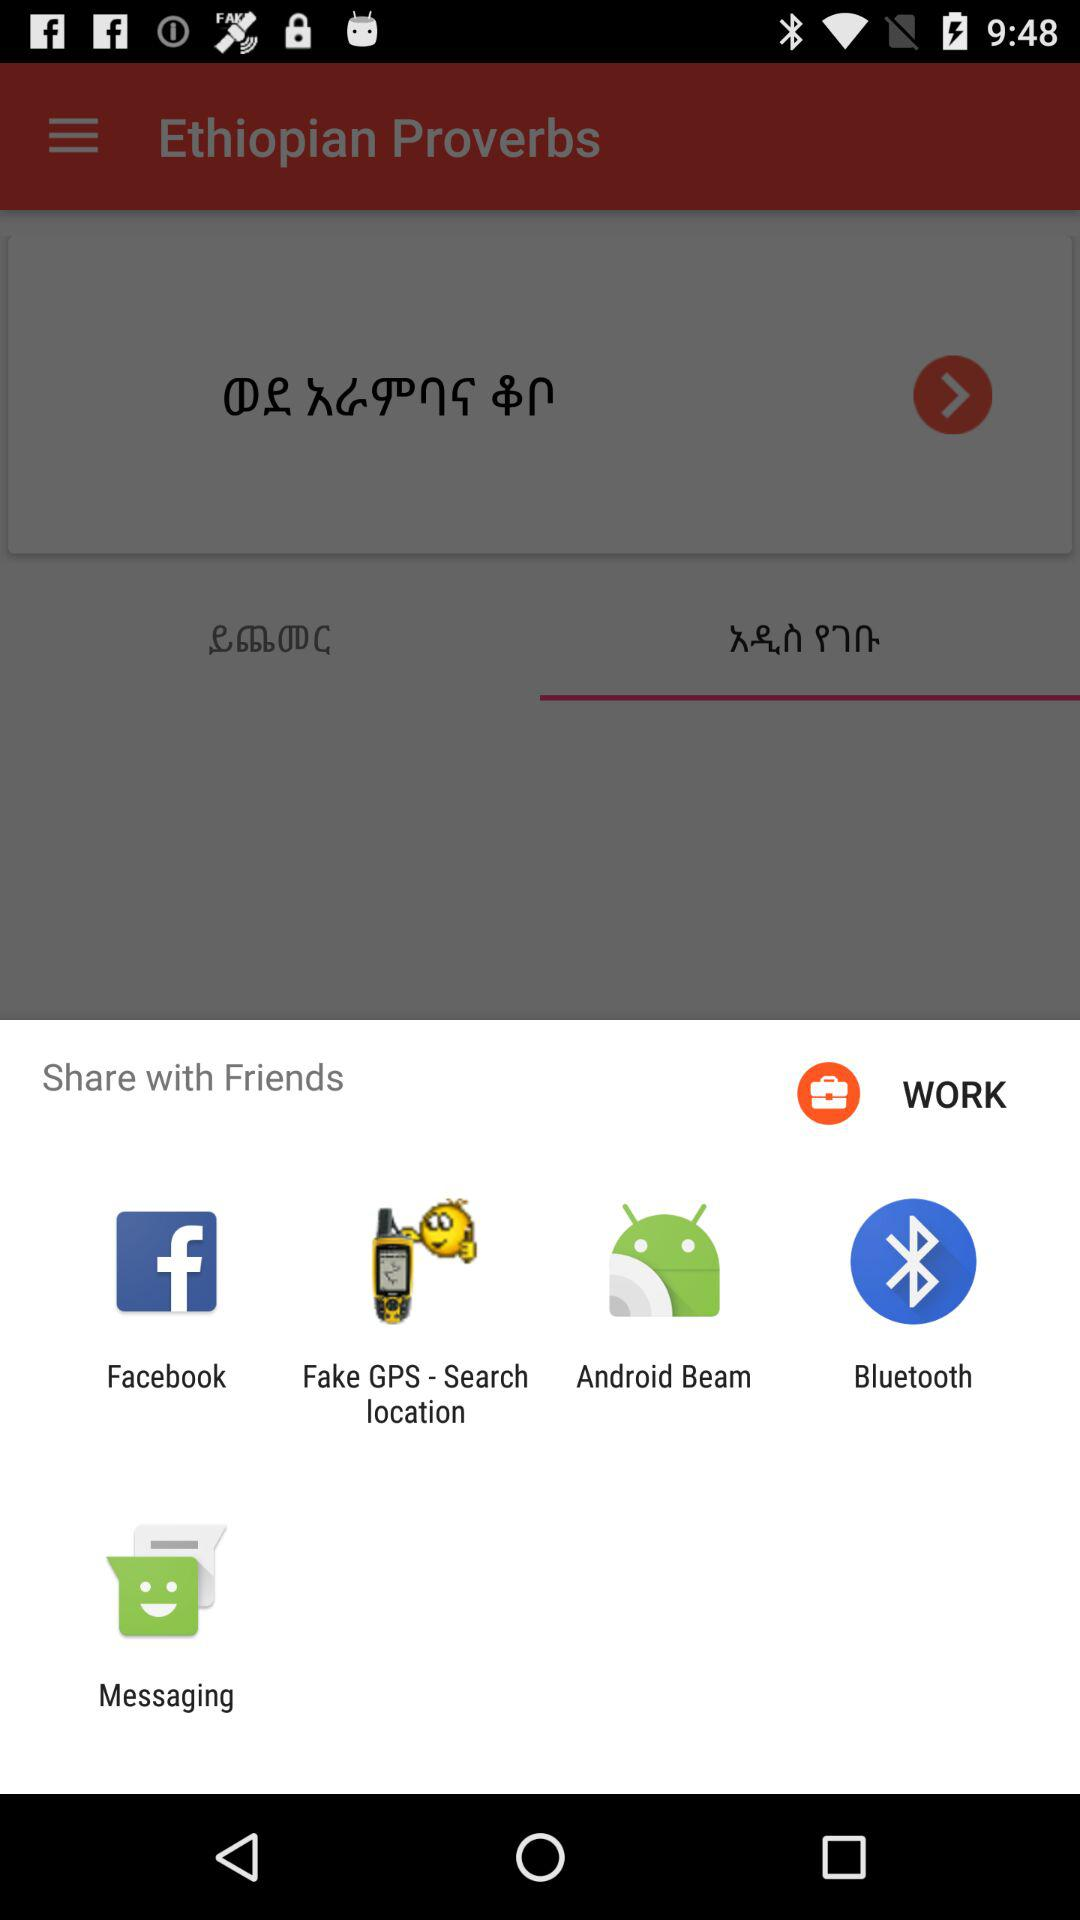Which application can I use to share? The applications are "Facebook", "Fake GPS - Search location", "Android Beam", "Bluetooth" and "Messaging". 